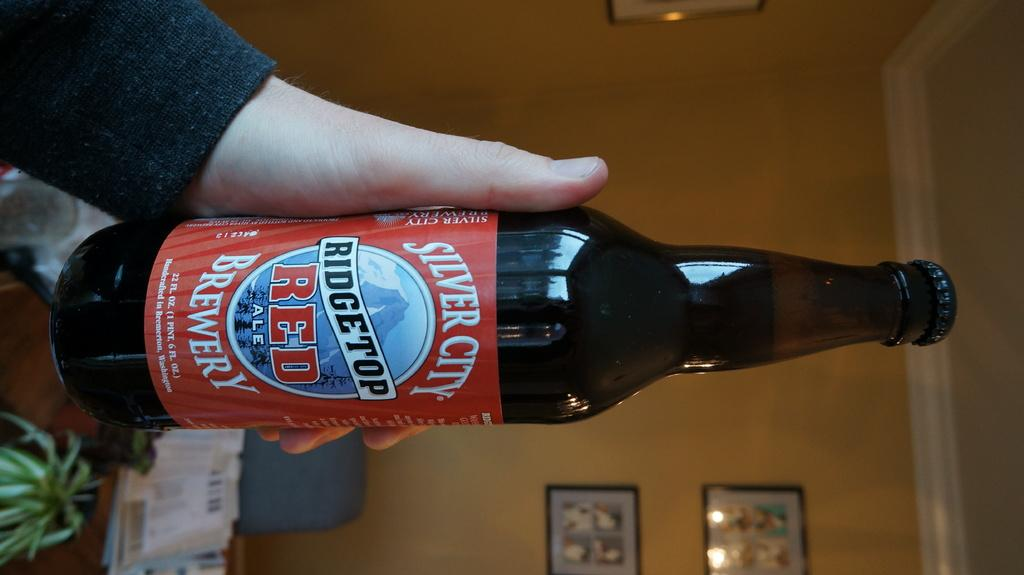<image>
Relay a brief, clear account of the picture shown. A person holding a bottle of Ridgetop Red Ale brewed from Silver City Brewery. 